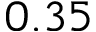Convert formula to latex. <formula><loc_0><loc_0><loc_500><loc_500>0 . 3 5</formula> 